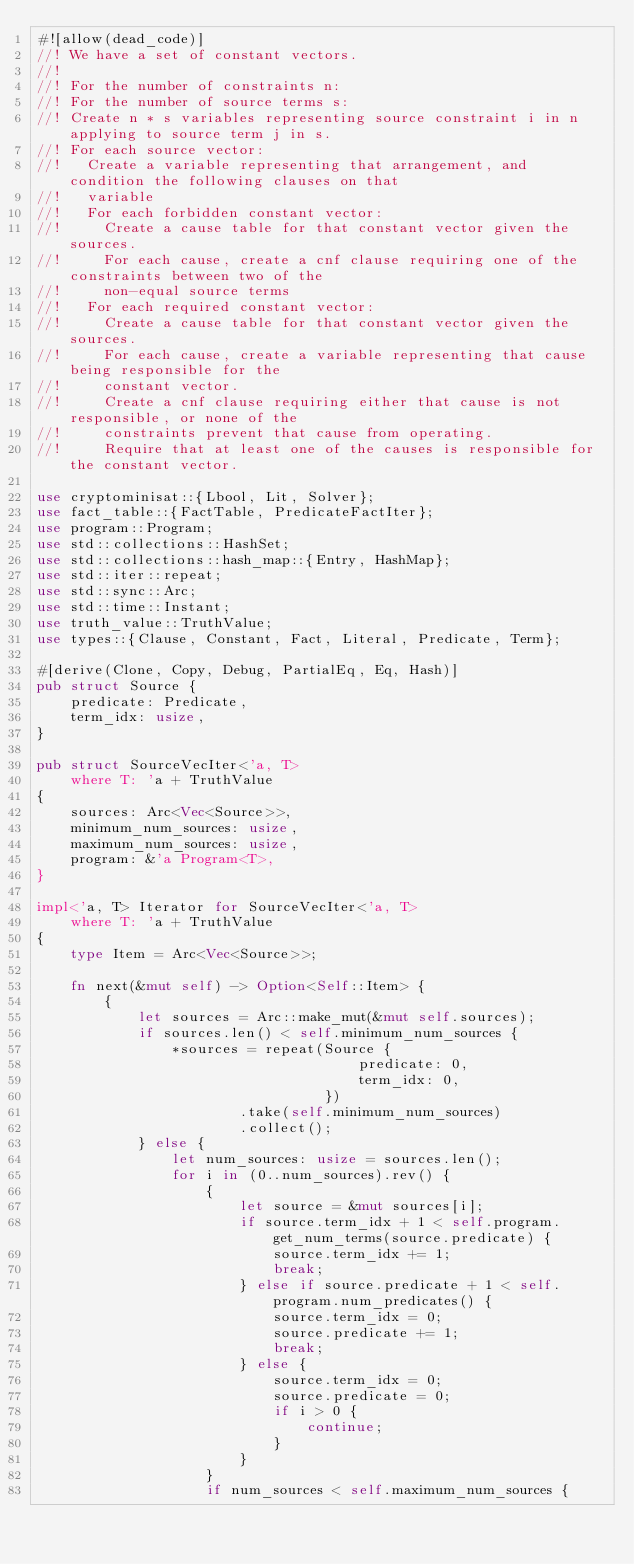<code> <loc_0><loc_0><loc_500><loc_500><_Rust_>#![allow(dead_code)]
//! We have a set of constant vectors.
//!
//! For the number of constraints n:
//! For the number of source terms s:
//! Create n * s variables representing source constraint i in n applying to source term j in s.
//! For each source vector:
//!   Create a variable representing that arrangement, and condition the following clauses on that
//!   variable
//!   For each forbidden constant vector:
//!     Create a cause table for that constant vector given the sources.
//!     For each cause, create a cnf clause requiring one of the constraints between two of the
//!     non-equal source terms
//!   For each required constant vector:
//!     Create a cause table for that constant vector given the sources.
//!     For each cause, create a variable representing that cause being responsible for the
//!     constant vector.
//!     Create a cnf clause requiring either that cause is not responsible, or none of the
//!     constraints prevent that cause from operating.
//!     Require that at least one of the causes is responsible for the constant vector.

use cryptominisat::{Lbool, Lit, Solver};
use fact_table::{FactTable, PredicateFactIter};
use program::Program;
use std::collections::HashSet;
use std::collections::hash_map::{Entry, HashMap};
use std::iter::repeat;
use std::sync::Arc;
use std::time::Instant;
use truth_value::TruthValue;
use types::{Clause, Constant, Fact, Literal, Predicate, Term};

#[derive(Clone, Copy, Debug, PartialEq, Eq, Hash)]
pub struct Source {
    predicate: Predicate,
    term_idx: usize,
}

pub struct SourceVecIter<'a, T>
    where T: 'a + TruthValue
{
    sources: Arc<Vec<Source>>,
    minimum_num_sources: usize,
    maximum_num_sources: usize,
    program: &'a Program<T>,
}

impl<'a, T> Iterator for SourceVecIter<'a, T>
    where T: 'a + TruthValue
{
    type Item = Arc<Vec<Source>>;

    fn next(&mut self) -> Option<Self::Item> {
        {
            let sources = Arc::make_mut(&mut self.sources);
            if sources.len() < self.minimum_num_sources {
                *sources = repeat(Source {
                                      predicate: 0,
                                      term_idx: 0,
                                  })
                        .take(self.minimum_num_sources)
                        .collect();
            } else {
                let num_sources: usize = sources.len();
                for i in (0..num_sources).rev() {
                    {
                        let source = &mut sources[i];
                        if source.term_idx + 1 < self.program.get_num_terms(source.predicate) {
                            source.term_idx += 1;
                            break;
                        } else if source.predicate + 1 < self.program.num_predicates() {
                            source.term_idx = 0;
                            source.predicate += 1;
                            break;
                        } else {
                            source.term_idx = 0;
                            source.predicate = 0;
                            if i > 0 {
                                continue;
                            }
                        }
                    }
                    if num_sources < self.maximum_num_sources {</code> 